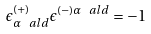<formula> <loc_0><loc_0><loc_500><loc_500>\epsilon ^ { ( + ) } _ { \alpha \ a l d } \epsilon ^ { ( - ) \alpha \ a l d } = - 1</formula> 